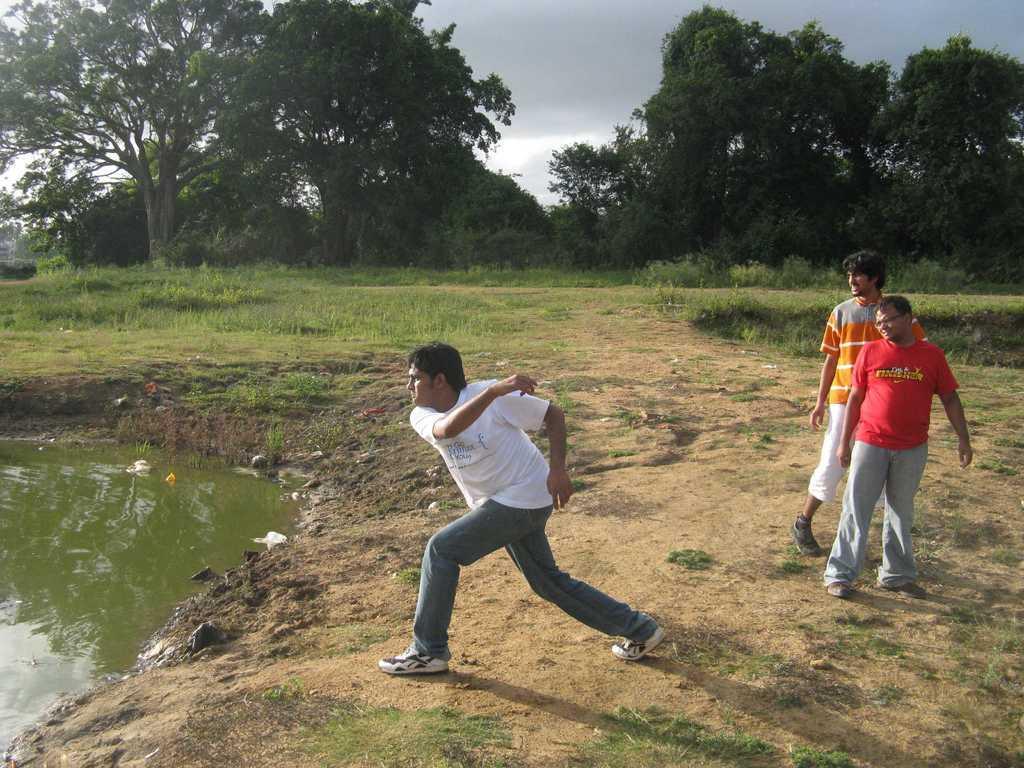Can you describe this image briefly? This image consists of three persons. In the front, the man is wearing a white T-shirt. On the right, the man is wearing a red T-shirt. At the bottom, there is green grass on the ground. On the left, we can see the water. In the background, there are trees. At the top, there is sky. 